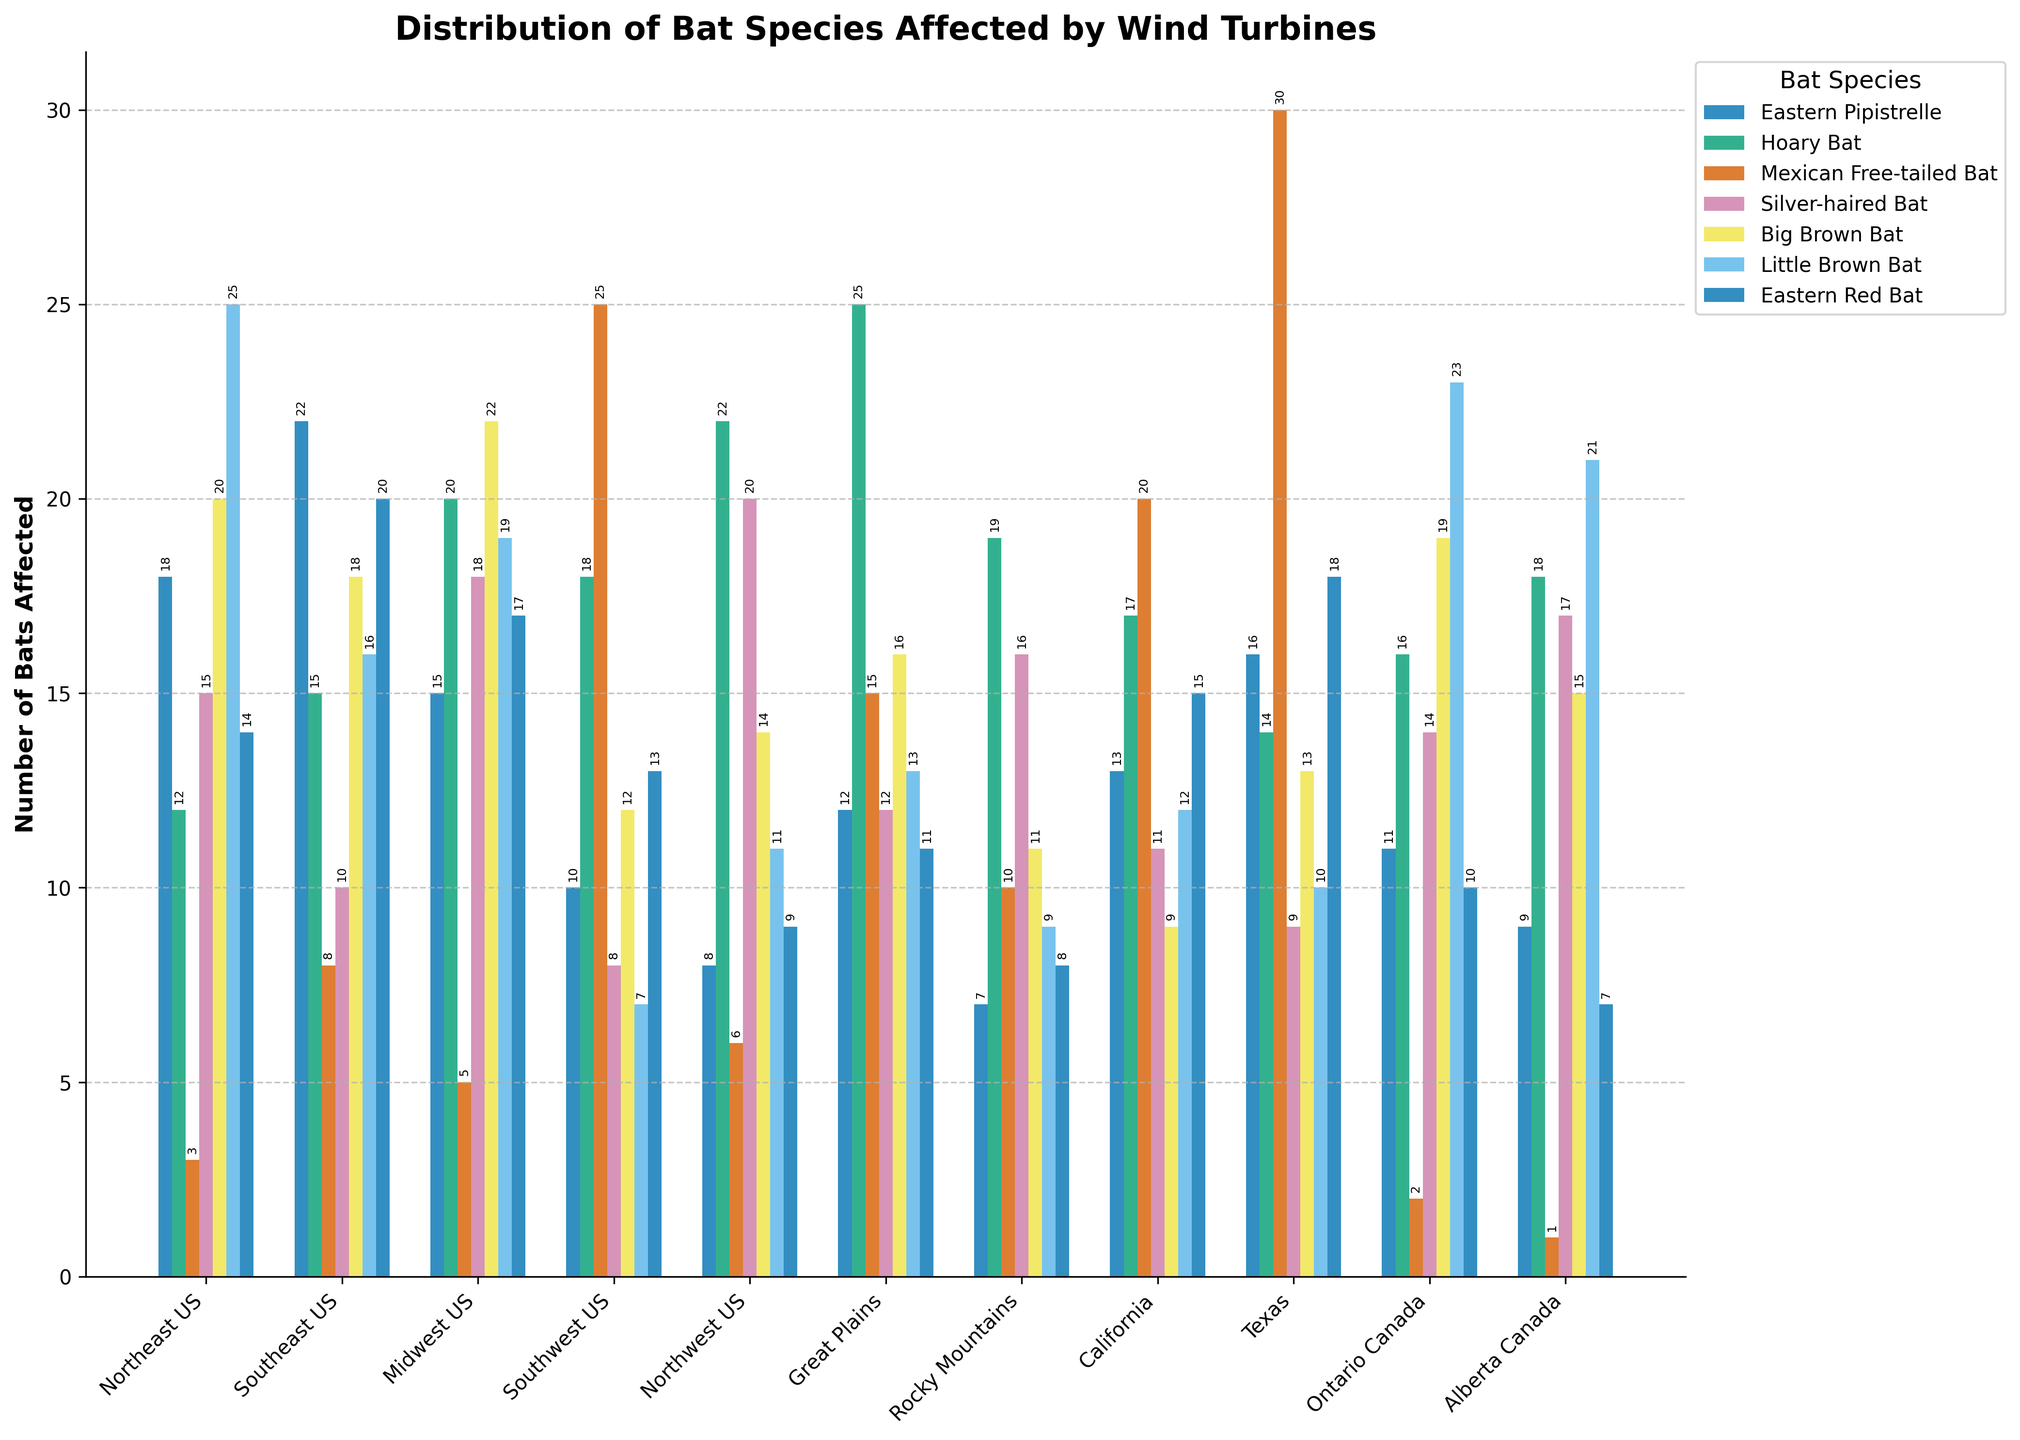Which region has the highest number of Mexican Free-tailed Bats affected by wind turbines? Look for the tallest bar representing Mexican Free-tailed Bats. This bar is in the Texas region, indicating the highest number.
Answer: Texas Which two bat species have the lowest total number affected in Ontario Canada? Add the values for each species in Ontario Canada. Eastern Pipistrelle (11), Hoary Bat (16), Mexican Free-tailed Bat (2), Silver-haired Bat (14), Big Brown Bat (19), Little Brown Bat (23), Eastern Red Bat (10). The two lowest totals are for Mexican Free-tailed Bat and Eastern Red Bat.
Answer: Mexican Free-tailed Bat and Eastern Red Bat What is the sum of Big Brown Bats affected in Northeast US, Midwest US, and Texas? Sum the values of Big Brown Bats for these regions: Northeast US (20), Midwest US (22), Texas (13). 20 + 22 + 13 = 55.
Answer: 55 Which region has more Little Brown Bats affected, Northeast US or Alberta Canada? Compare the heights of the bars representing Little Brown Bats for these regions. Northeast US has 25, and Alberta Canada has 21. Therefore, Northeast US has more.
Answer: Northeast US What is the average number of Hoary Bats affected in all the regions? Sum the number of Hoary Bats in each region and divide by the number of regions. (12 + 15 + 20 + 18 + 22 + 25 + 19 + 17 + 14 + 16 + 18) / 11 = 17.6363.
Answer: 17.64 Which species has the highest total number of bats affected in the Great Plains region? Look at the values for the Great Plains region: Eastern Pipistrelle (12), Hoary Bat (25), Mexican Free-tailed Bat (15), Silver-haired Bat (12), Big Brown Bat (16), Little Brown Bat (13), Eastern Red Bat (11). The highest number is for Hoary Bat.
Answer: Hoary Bat Are more bats affected by wind turbines in the Southeast US or in California? Sum the values for each species in both regions: Southeast US (22+15+8+10+18+16+20) = 109, California (13+17+20+11+9+12+15) = 97. Southeast US has more bats affected.
Answer: Southeast US Which bat species is least affected by wind turbines in the Rocky Mountains region? Look for the smallest bar height representing bat species in the Rocky Mountains region. This is Eastern Pipistrelle with a value of 7.
Answer: Eastern Pipistrelle 